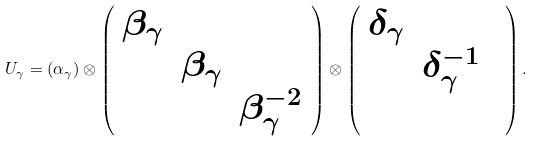Convert formula to latex. <formula><loc_0><loc_0><loc_500><loc_500>U _ { \gamma } = ( \alpha _ { \gamma } ) \otimes \left ( \begin{array} { c c c } \beta _ { \gamma } & & \\ & \beta _ { \gamma } & \\ & & \beta ^ { - 2 } _ { \gamma } \end{array} \right ) \otimes \left ( \begin{array} { c c c } \delta _ { \gamma } & & \\ & \delta ^ { - 1 } _ { \gamma } & \\ & & \end{array} \right ) .</formula> 